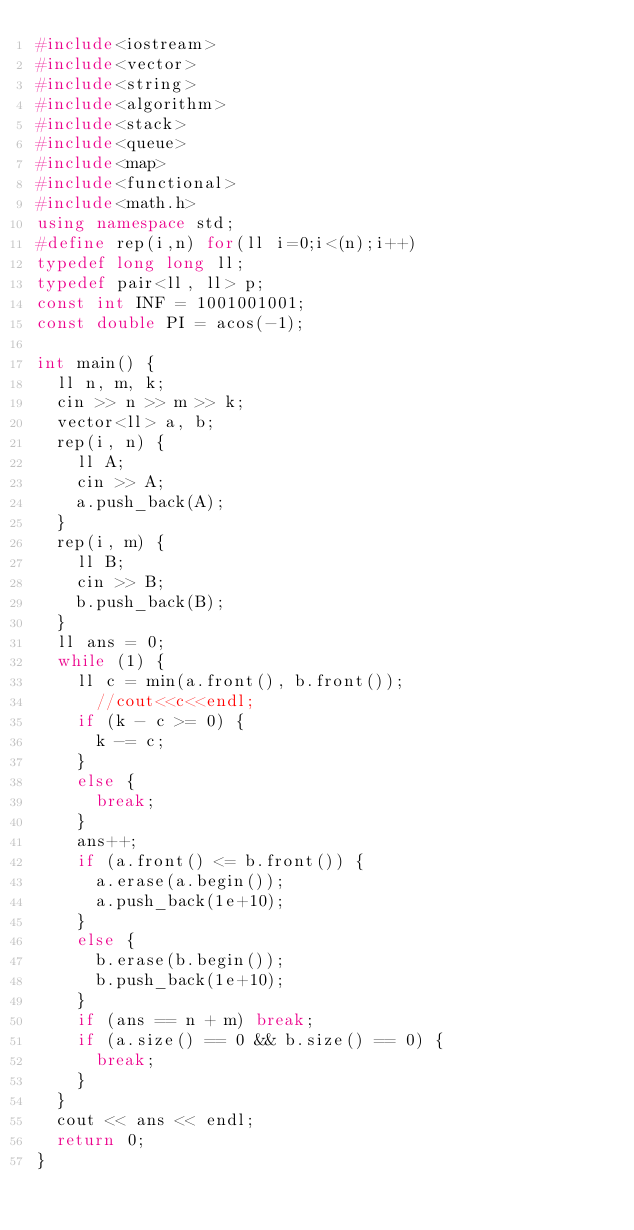Convert code to text. <code><loc_0><loc_0><loc_500><loc_500><_C++_>#include<iostream>
#include<vector>
#include<string>
#include<algorithm>
#include<stack>
#include<queue>
#include<map>
#include<functional>
#include<math.h>
using namespace std;
#define rep(i,n) for(ll i=0;i<(n);i++)
typedef long long ll;
typedef pair<ll, ll> p;
const int INF = 1001001001;
const double PI = acos(-1);

int main() {
	ll n, m, k;
	cin >> n >> m >> k;
	vector<ll> a, b;
	rep(i, n) {
		ll A;
		cin >> A;
		a.push_back(A);
	}
	rep(i, m) {
		ll B;
		cin >> B;
		b.push_back(B);
	}
	ll ans = 0;
	while (1) {
		ll c = min(a.front(), b.front());
      //cout<<c<<endl;
		if (k - c >= 0) {
			k -= c;
		}
		else {
			break;
		}
		ans++;
		if (a.front() <= b.front()) {
			a.erase(a.begin());
			a.push_back(1e+10);
		}
		else {
			b.erase(b.begin());
			b.push_back(1e+10);
		}
		if (ans == n + m) break;
		if (a.size() == 0 && b.size() == 0) {
			break;
		}
	}
	cout << ans << endl;
	return 0;
}</code> 